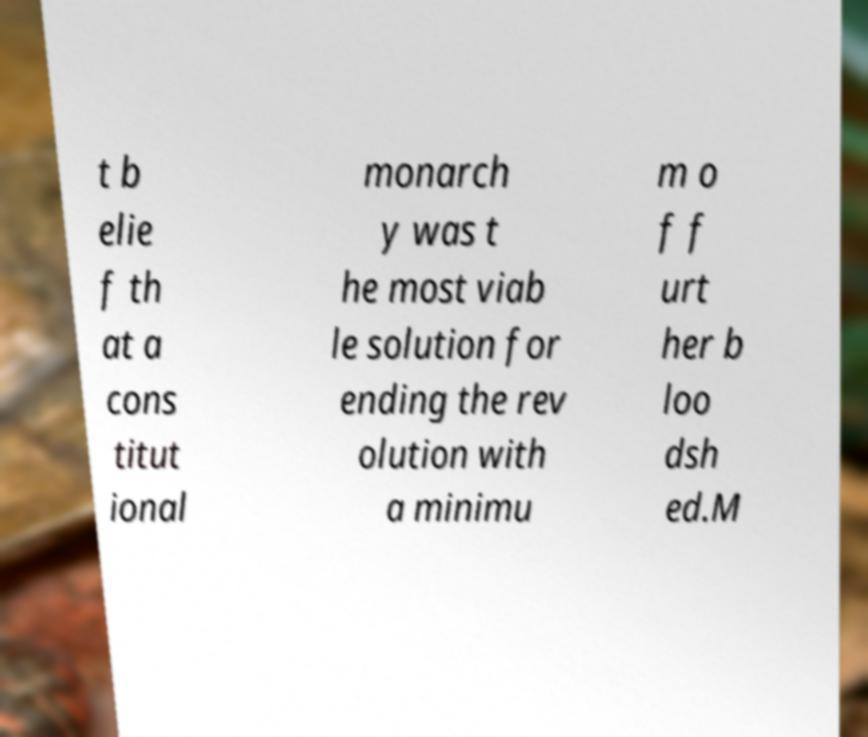Can you accurately transcribe the text from the provided image for me? t b elie f th at a cons titut ional monarch y was t he most viab le solution for ending the rev olution with a minimu m o f f urt her b loo dsh ed.M 